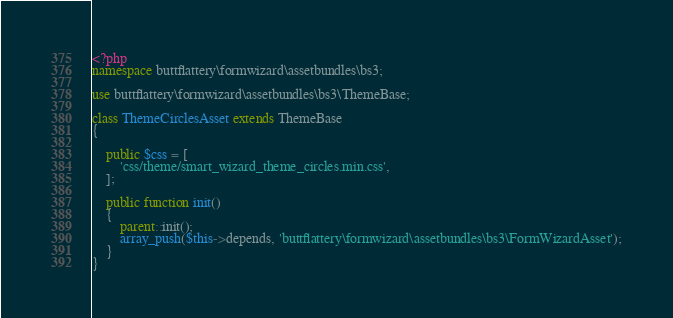Convert code to text. <code><loc_0><loc_0><loc_500><loc_500><_PHP_><?php
namespace buttflattery\formwizard\assetbundles\bs3;

use buttflattery\formwizard\assetbundles\bs3\ThemeBase;

class ThemeCirclesAsset extends ThemeBase
{

    public $css = [
        'css/theme/smart_wizard_theme_circles.min.css',
    ];

    public function init()
    {
        parent::init();
        array_push($this->depends, 'buttflattery\formwizard\assetbundles\bs3\FormWizardAsset');
    }
}
</code> 